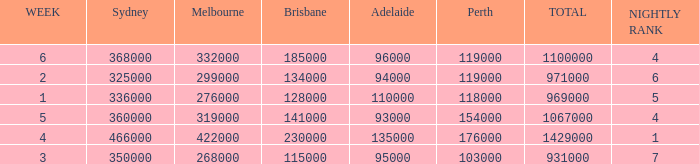What was the rating in Brisbane the week it was 276000 in Melbourne?  128000.0. 